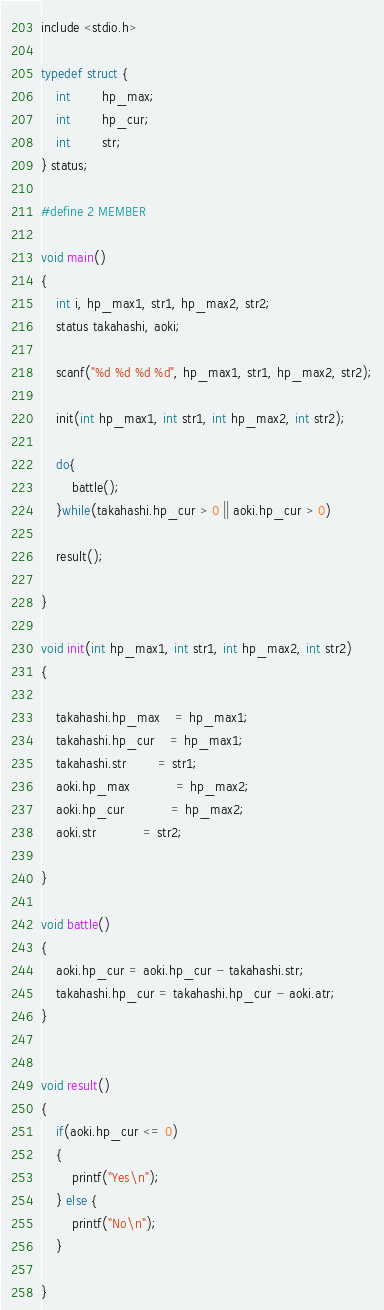Convert code to text. <code><loc_0><loc_0><loc_500><loc_500><_C_>include <stdio.h>

typedef struct {
	int		hp_max;
	int		hp_cur;
	int		str;
} status;

#define 2 MEMBER

void main()
{
	int i, hp_max1, str1, hp_max2, str2;
	status takahashi, aoki;
	
	scanf("%d %d %d %d", hp_max1, str1, hp_max2, str2);
	
	init(int hp_max1, int str1, int hp_max2, int str2);
	
	do{
		battle();
	}while(takahashi.hp_cur > 0 || aoki.hp_cur > 0)
	
	result();
	
}

void init(int hp_max1, int str1, int hp_max2, int str2)
{
	
	takahashi.hp_max	= hp_max1;
	takahashi.hp_cur	= hp_max1;
	takahashi.str		= str1;
	aoki.hp_max			= hp_max2;
	aoki.hp_cur			= hp_max2;
	aoki.str			= str2;
	
}

void battle()
{
	aoki.hp_cur = aoki.hp_cur - takahashi.str;
	takahashi.hp_cur = takahashi.hp_cur - aoki.atr;
}


void result()
{
	if(aoki.hp_cur <= 0)
	{
		printf("Yes\n");
	} else {
		printf("No\n");
	}
	
}</code> 